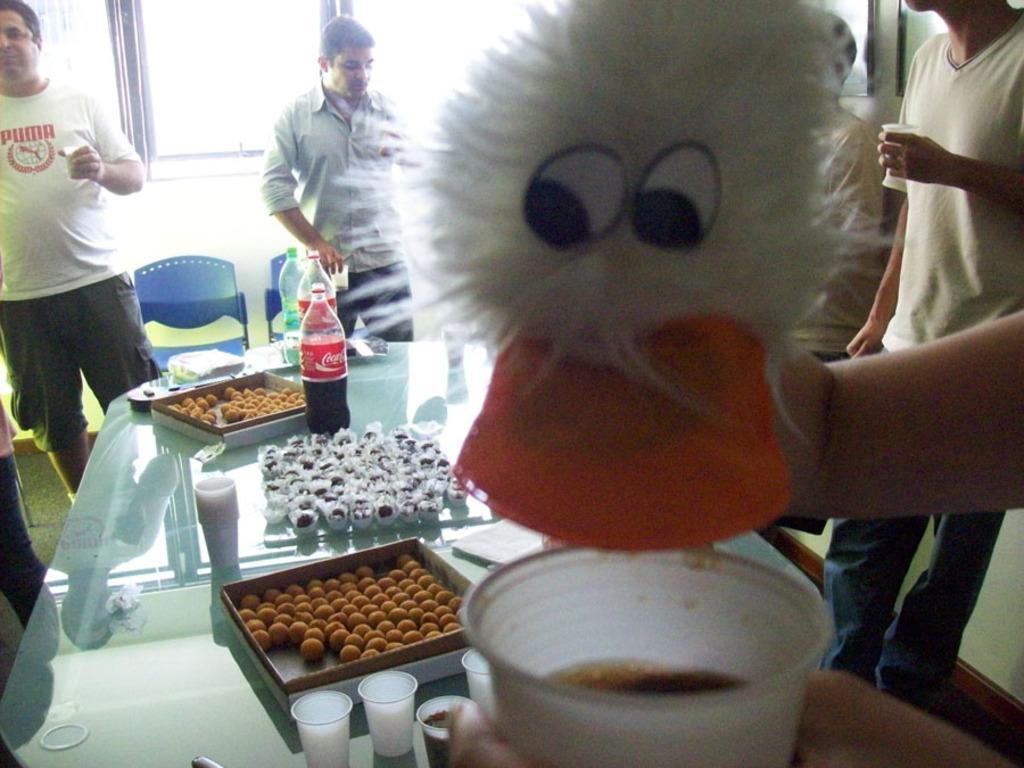Can you describe this image briefly? In this picture I can see many people were standing near to the table. On the table I can see the coke bottle, bottles, jar, milk, water bottle and other objects. Beside them I can see the chairs. At the top I can see the windows. 